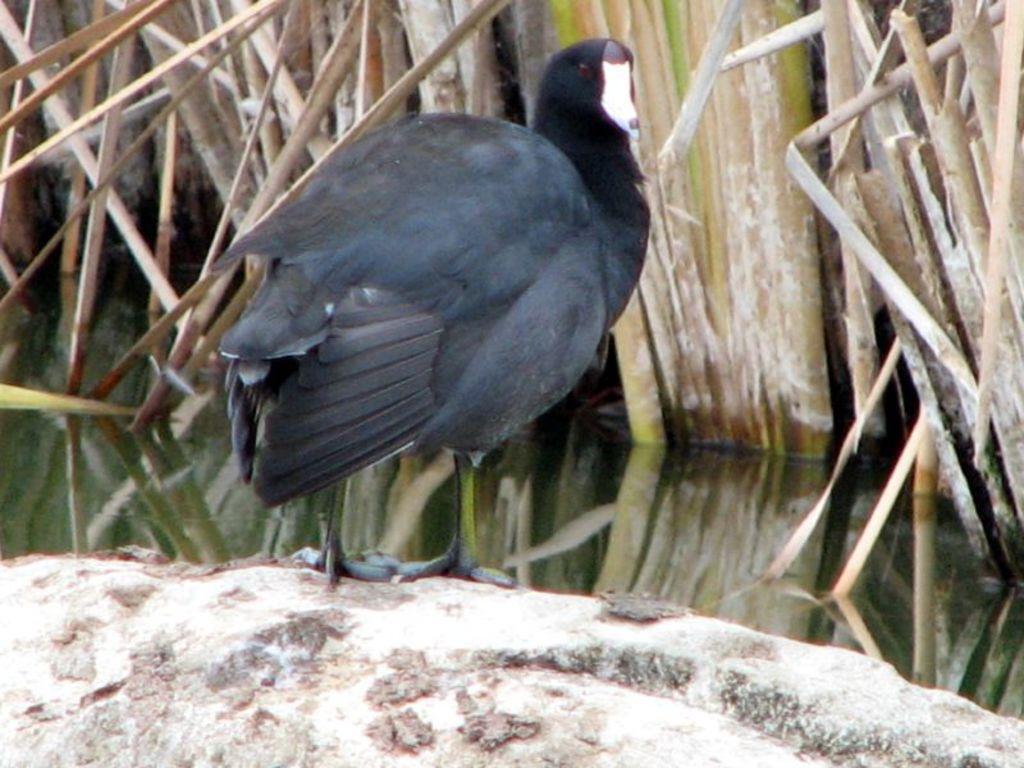Please provide a concise description of this image. In this picture we can see a black bird on an object. Behind the bird, there is water and grass. 